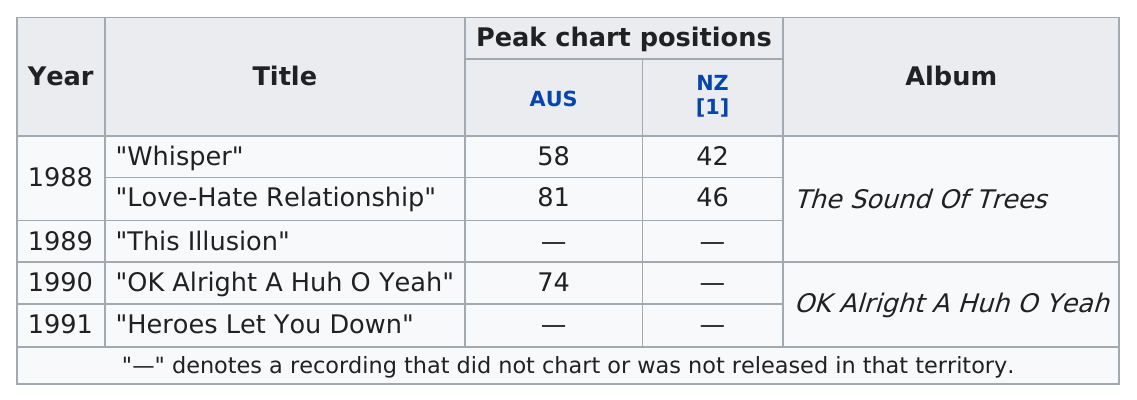Mention a couple of crucial points in this snapshot. The band Schnell Fenster released an album called "The Sound of Trees," which produced the most singles to appear on the Australian peak chart. The single "Whisper" by the band Schnell Fenster reached the highest position on the New Zealand peak chart. The band Schnell Fenster's first single to make the Australian peak chart was "Whisper. 